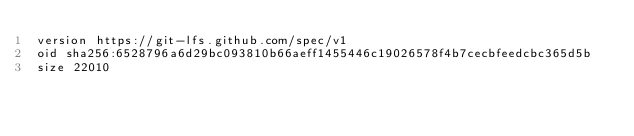<code> <loc_0><loc_0><loc_500><loc_500><_HTML_>version https://git-lfs.github.com/spec/v1
oid sha256:6528796a6d29bc093810b66aeff1455446c19026578f4b7cecbfeedcbc365d5b
size 22010
</code> 